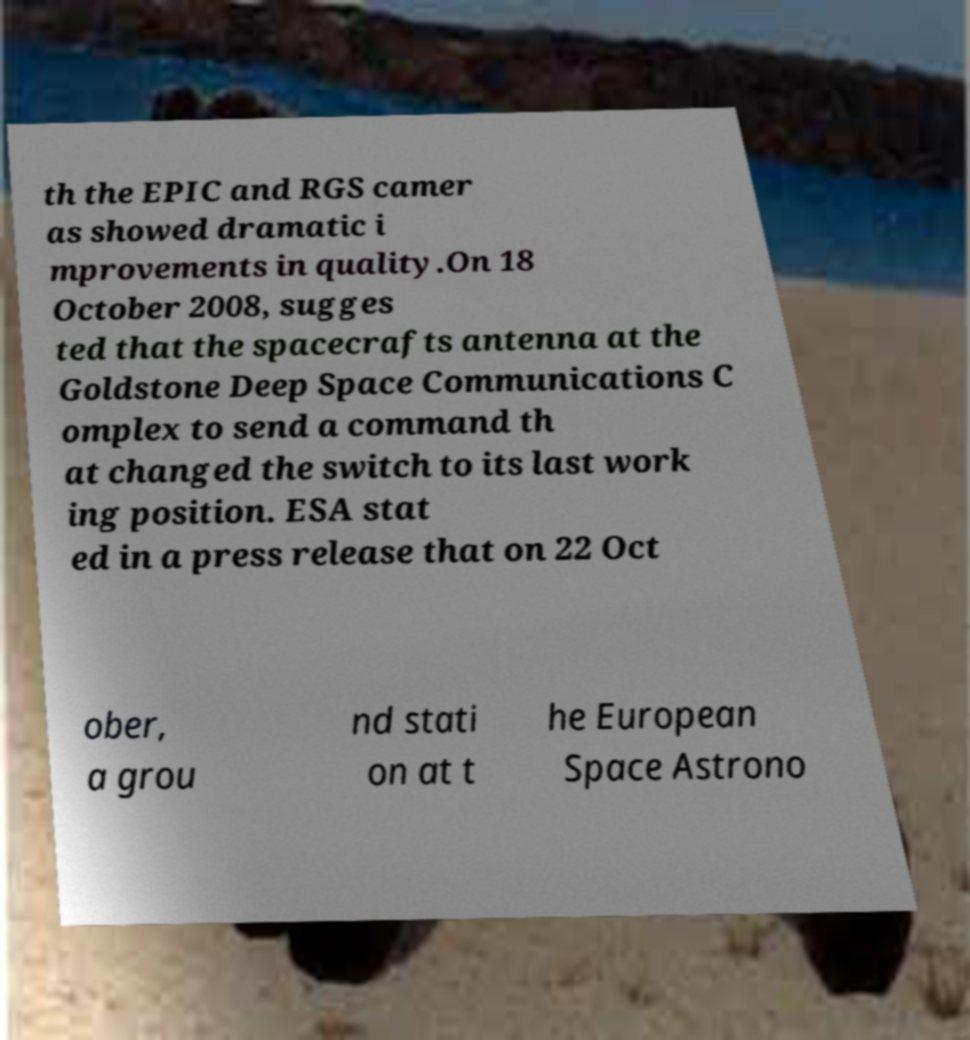Can you read and provide the text displayed in the image?This photo seems to have some interesting text. Can you extract and type it out for me? th the EPIC and RGS camer as showed dramatic i mprovements in quality.On 18 October 2008, sugges ted that the spacecrafts antenna at the Goldstone Deep Space Communications C omplex to send a command th at changed the switch to its last work ing position. ESA stat ed in a press release that on 22 Oct ober, a grou nd stati on at t he European Space Astrono 